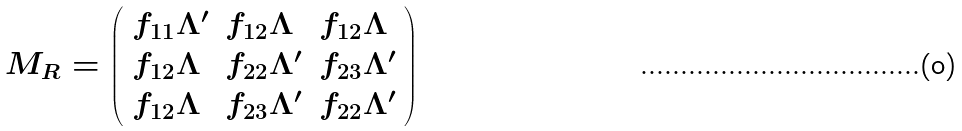<formula> <loc_0><loc_0><loc_500><loc_500>M _ { R } = \left ( \begin{array} { l l l } f _ { 1 1 } \Lambda ^ { \prime } & f _ { 1 2 } \Lambda & f _ { 1 2 } \Lambda \\ f _ { 1 2 } \Lambda & f _ { 2 2 } \Lambda ^ { \prime } & f _ { 2 3 } \Lambda ^ { \prime } \\ f _ { 1 2 } \Lambda & f _ { 2 3 } \Lambda ^ { \prime } & f _ { 2 2 } \Lambda ^ { \prime } \end{array} \right )</formula> 